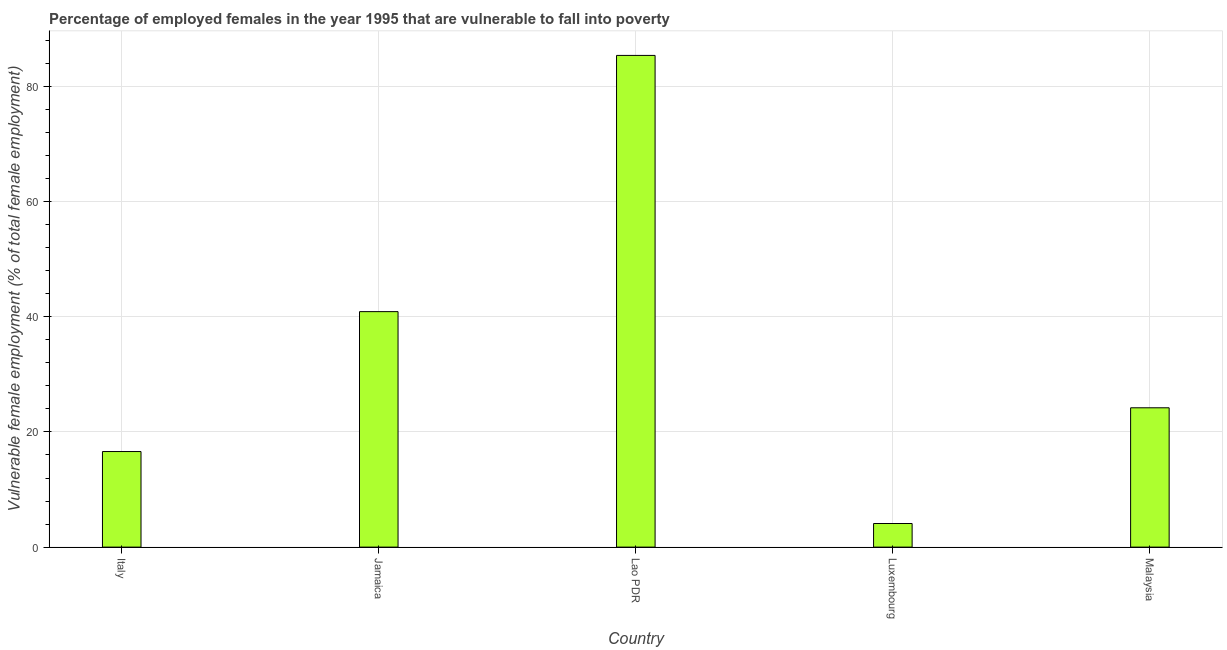What is the title of the graph?
Give a very brief answer. Percentage of employed females in the year 1995 that are vulnerable to fall into poverty. What is the label or title of the Y-axis?
Offer a very short reply. Vulnerable female employment (% of total female employment). What is the percentage of employed females who are vulnerable to fall into poverty in Lao PDR?
Ensure brevity in your answer.  85.4. Across all countries, what is the maximum percentage of employed females who are vulnerable to fall into poverty?
Give a very brief answer. 85.4. Across all countries, what is the minimum percentage of employed females who are vulnerable to fall into poverty?
Offer a very short reply. 4.1. In which country was the percentage of employed females who are vulnerable to fall into poverty maximum?
Keep it short and to the point. Lao PDR. In which country was the percentage of employed females who are vulnerable to fall into poverty minimum?
Your response must be concise. Luxembourg. What is the sum of the percentage of employed females who are vulnerable to fall into poverty?
Make the answer very short. 171.2. What is the difference between the percentage of employed females who are vulnerable to fall into poverty in Lao PDR and Luxembourg?
Your answer should be compact. 81.3. What is the average percentage of employed females who are vulnerable to fall into poverty per country?
Your response must be concise. 34.24. What is the median percentage of employed females who are vulnerable to fall into poverty?
Make the answer very short. 24.2. In how many countries, is the percentage of employed females who are vulnerable to fall into poverty greater than 84 %?
Keep it short and to the point. 1. What is the ratio of the percentage of employed females who are vulnerable to fall into poverty in Italy to that in Lao PDR?
Your answer should be compact. 0.19. Is the difference between the percentage of employed females who are vulnerable to fall into poverty in Italy and Malaysia greater than the difference between any two countries?
Offer a terse response. No. What is the difference between the highest and the second highest percentage of employed females who are vulnerable to fall into poverty?
Your answer should be compact. 44.5. Is the sum of the percentage of employed females who are vulnerable to fall into poverty in Jamaica and Malaysia greater than the maximum percentage of employed females who are vulnerable to fall into poverty across all countries?
Provide a succinct answer. No. What is the difference between the highest and the lowest percentage of employed females who are vulnerable to fall into poverty?
Your answer should be very brief. 81.3. In how many countries, is the percentage of employed females who are vulnerable to fall into poverty greater than the average percentage of employed females who are vulnerable to fall into poverty taken over all countries?
Your response must be concise. 2. How many bars are there?
Your answer should be compact. 5. Are all the bars in the graph horizontal?
Your answer should be compact. No. How many countries are there in the graph?
Your answer should be very brief. 5. What is the difference between two consecutive major ticks on the Y-axis?
Your answer should be very brief. 20. Are the values on the major ticks of Y-axis written in scientific E-notation?
Your response must be concise. No. What is the Vulnerable female employment (% of total female employment) of Italy?
Ensure brevity in your answer.  16.6. What is the Vulnerable female employment (% of total female employment) of Jamaica?
Keep it short and to the point. 40.9. What is the Vulnerable female employment (% of total female employment) in Lao PDR?
Ensure brevity in your answer.  85.4. What is the Vulnerable female employment (% of total female employment) of Luxembourg?
Ensure brevity in your answer.  4.1. What is the Vulnerable female employment (% of total female employment) in Malaysia?
Keep it short and to the point. 24.2. What is the difference between the Vulnerable female employment (% of total female employment) in Italy and Jamaica?
Ensure brevity in your answer.  -24.3. What is the difference between the Vulnerable female employment (% of total female employment) in Italy and Lao PDR?
Your answer should be very brief. -68.8. What is the difference between the Vulnerable female employment (% of total female employment) in Italy and Luxembourg?
Offer a terse response. 12.5. What is the difference between the Vulnerable female employment (% of total female employment) in Italy and Malaysia?
Your answer should be compact. -7.6. What is the difference between the Vulnerable female employment (% of total female employment) in Jamaica and Lao PDR?
Keep it short and to the point. -44.5. What is the difference between the Vulnerable female employment (% of total female employment) in Jamaica and Luxembourg?
Your answer should be very brief. 36.8. What is the difference between the Vulnerable female employment (% of total female employment) in Jamaica and Malaysia?
Your answer should be very brief. 16.7. What is the difference between the Vulnerable female employment (% of total female employment) in Lao PDR and Luxembourg?
Make the answer very short. 81.3. What is the difference between the Vulnerable female employment (% of total female employment) in Lao PDR and Malaysia?
Give a very brief answer. 61.2. What is the difference between the Vulnerable female employment (% of total female employment) in Luxembourg and Malaysia?
Make the answer very short. -20.1. What is the ratio of the Vulnerable female employment (% of total female employment) in Italy to that in Jamaica?
Ensure brevity in your answer.  0.41. What is the ratio of the Vulnerable female employment (% of total female employment) in Italy to that in Lao PDR?
Give a very brief answer. 0.19. What is the ratio of the Vulnerable female employment (% of total female employment) in Italy to that in Luxembourg?
Ensure brevity in your answer.  4.05. What is the ratio of the Vulnerable female employment (% of total female employment) in Italy to that in Malaysia?
Your answer should be compact. 0.69. What is the ratio of the Vulnerable female employment (% of total female employment) in Jamaica to that in Lao PDR?
Your response must be concise. 0.48. What is the ratio of the Vulnerable female employment (% of total female employment) in Jamaica to that in Luxembourg?
Provide a short and direct response. 9.98. What is the ratio of the Vulnerable female employment (% of total female employment) in Jamaica to that in Malaysia?
Provide a succinct answer. 1.69. What is the ratio of the Vulnerable female employment (% of total female employment) in Lao PDR to that in Luxembourg?
Give a very brief answer. 20.83. What is the ratio of the Vulnerable female employment (% of total female employment) in Lao PDR to that in Malaysia?
Offer a very short reply. 3.53. What is the ratio of the Vulnerable female employment (% of total female employment) in Luxembourg to that in Malaysia?
Offer a very short reply. 0.17. 